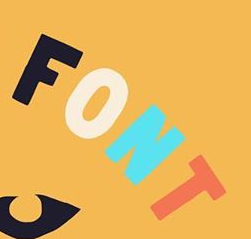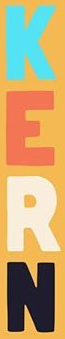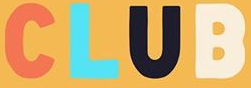Read the text from these images in sequence, separated by a semicolon. FONT; KERN; CLUB 